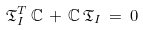<formula> <loc_0><loc_0><loc_500><loc_500>\mathfrak { T } _ { I } ^ { T } \, \mathbb { C } \, + \, \mathbb { C } \, \mathfrak { T } _ { I } \, = \, 0</formula> 